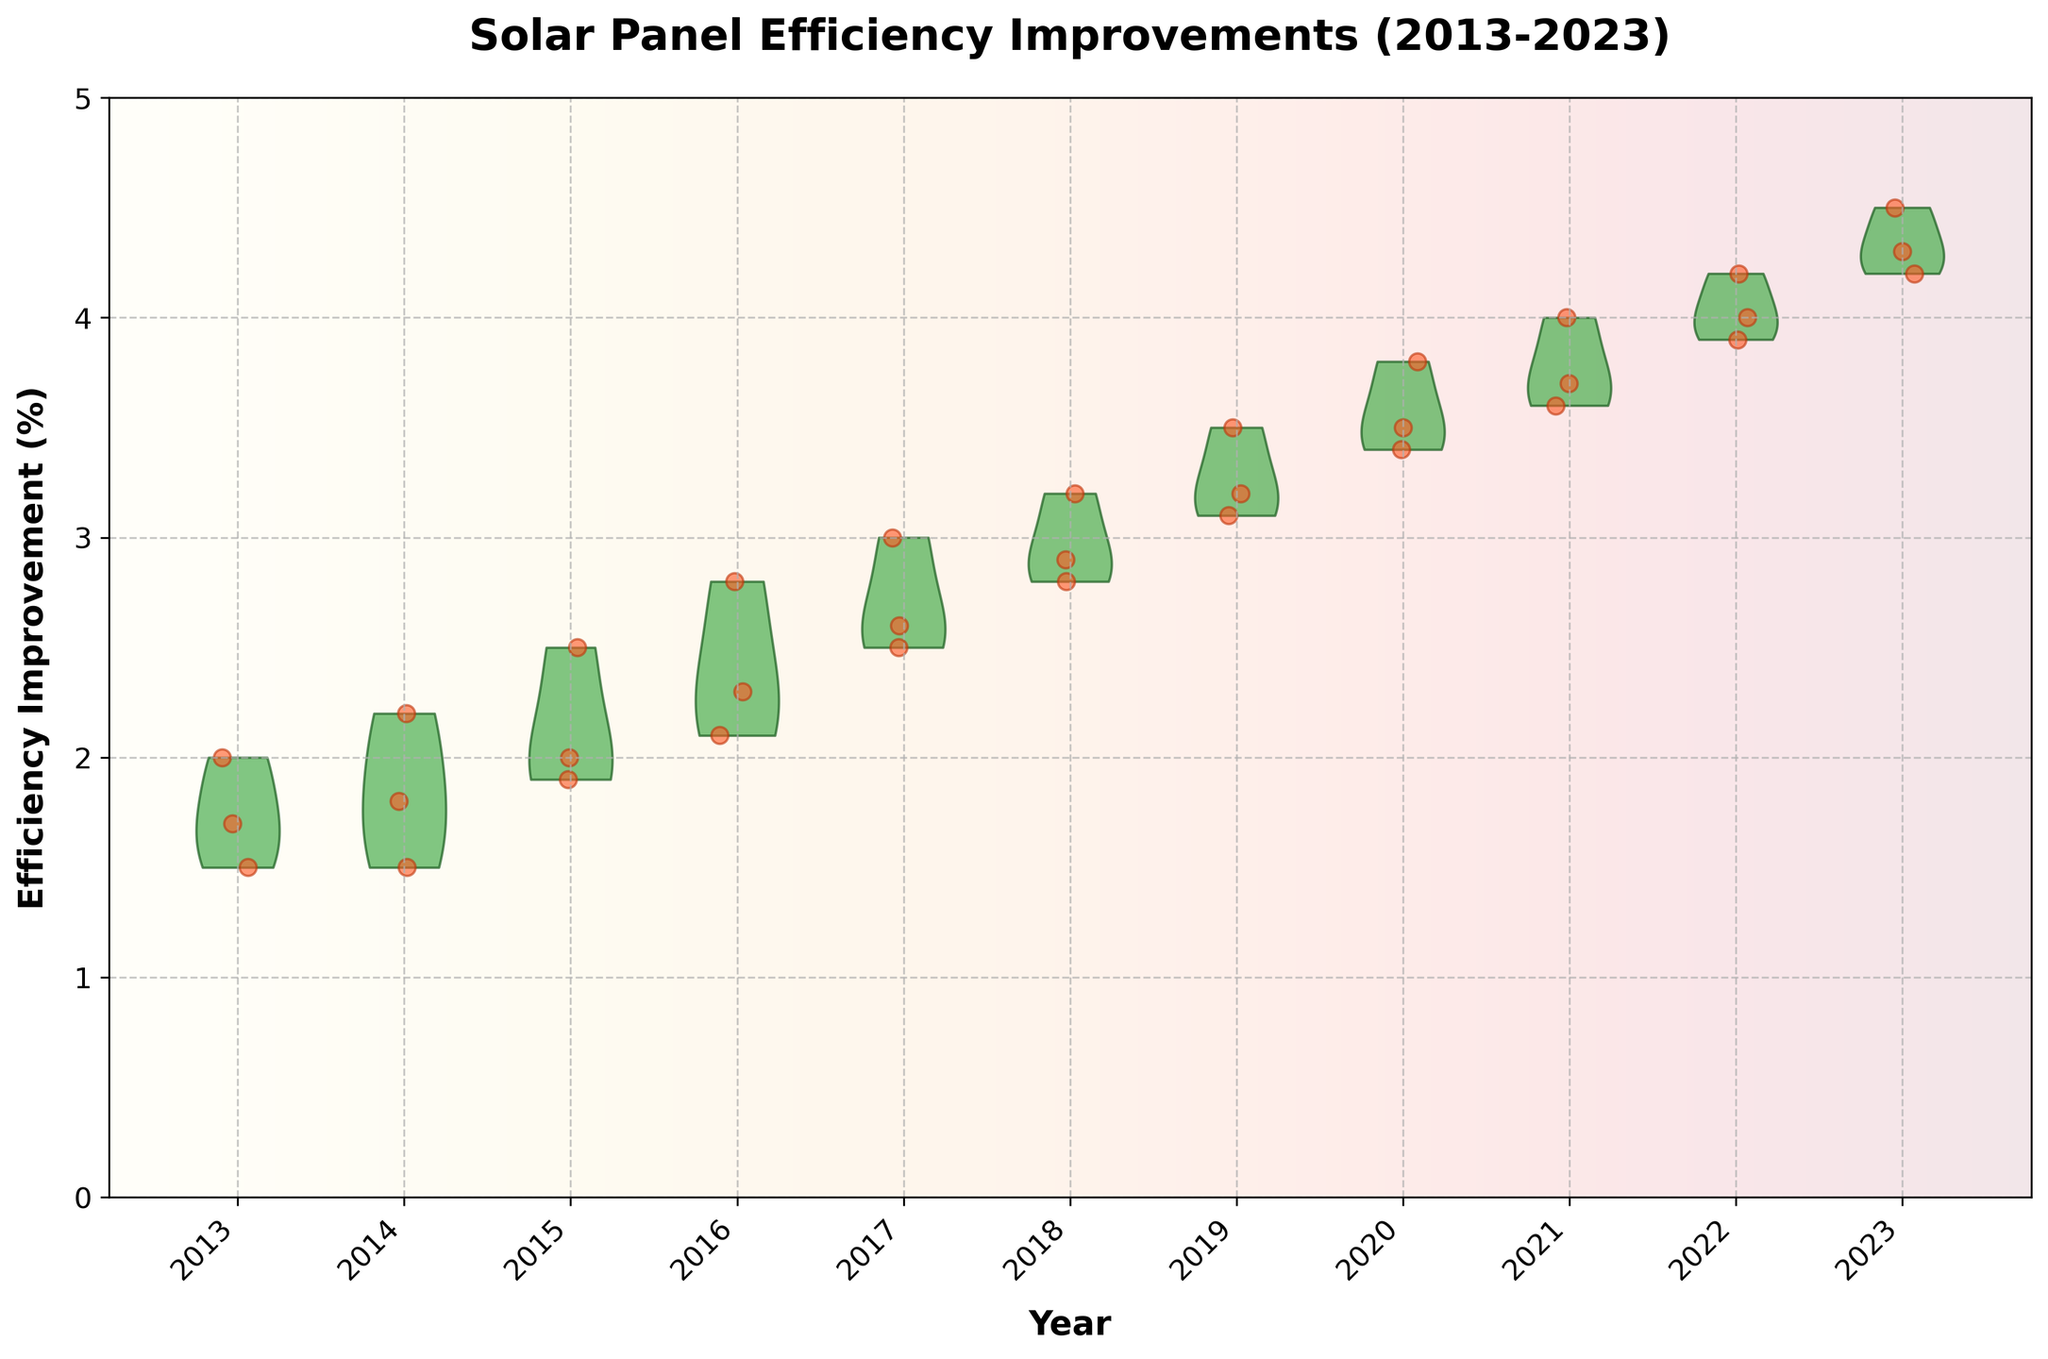What is the title of the plot? The title is the text at the top of the plot which acts as a summary of the data being visualized.
Answer: Solar Panel Efficiency Improvements (2013-2023) What is the range of efficiency improvements shown in the plot? The range is determined by the lowest and highest values on the y-axis. The lowest efficiency improvement is 0% and the highest is 5%.
Answer: 0% to 5% Which year shows the highest median efficiency improvement based on the violin shapes? The median can be estimated by looking at the thickest part of the violins. 2023 shows the highest median efficiency improvement, as the violin is positioned higher than other years.
Answer: 2023 How does the efficiency improvement in 2013 compare with that in 2023? To compare, observe the overall positions of the violins and the scatter points for these years. In 2013, the efficiency improvements are much lower than in 2023, indicating substantial improvement over time.
Answer: Much lower in 2013 than in 2023 Are there any years where the efficiency improvement has a narrow spread? The spread can be observed by the width of the violin shapes. Narrow spreads are shown by thinner violins. The year 2020 has a relatively narrow spread compared to other years.
Answer: 2020 Which years seem to have outliers based on the scatter points? Outliers are individual points that are far from the main cluster of scatter points or violin shapes. The years 2023 and 2022 have scatter points that are relatively far from other points, indicating possible outliers.
Answer: 2023 and 2022 What noticeable trend can be observed from the efficiency improvements from 2013 to 2023? Observing the trend over time involves looking at the general shift of the violin shapes upwards. There is a consistent increase in efficiency improvements from 2013 to 2023.
Answer: Increasing trend Approximately how many data points are plotted in the year 2018? By counting the scatter points visible around the violin shape for 2018, you can estimate the number of data points. There are about 3 points.
Answer: 3 Which year has the widest range of efficiency improvements based on the violin shapes? The range within each year can be visualized by the height and spread of the violins. The year 2020 has a noticeably wide range of efficiency improvements.
Answer: 2020 